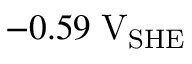<formula> <loc_0><loc_0><loc_500><loc_500>- 0 . 5 9 \, V _ { S H E }</formula> 